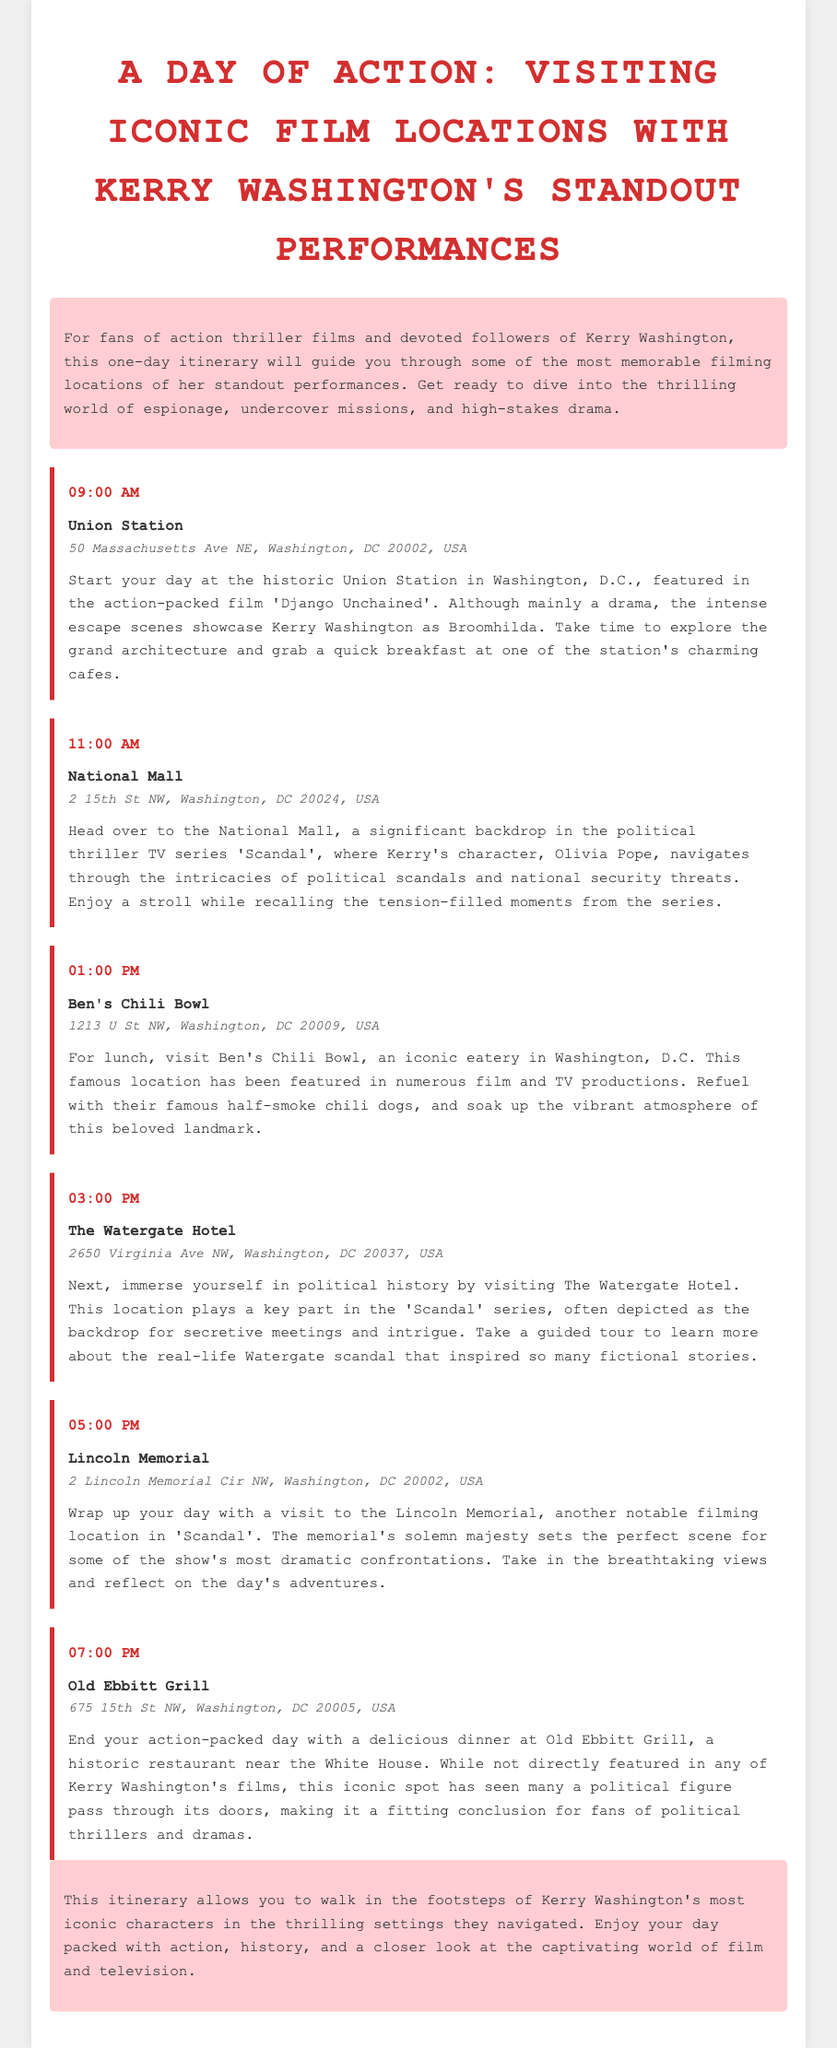what time does the day start? The itinerary starts at 09:00 AM, which is the time of the first event listed.
Answer: 09:00 AM where is the first location on the itinerary? The first location mentioned in the itinerary is Union Station.
Answer: Union Station what meal is planned at Ben's Chili Bowl? The document specifies that lunch is planned at Ben's Chili Bowl, where a meal consists of half-smoke chili dogs.
Answer: lunch which film features Union Station as a filming location? The itinerary indicates that Union Station is featured in 'Django Unchained'.
Answer: Django Unchained what significant political series is mentioned in relation to the National Mall? The National Mall is highlighted in connection with the political thriller TV series 'Scandal'.
Answer: Scandal how many events are scheduled for the day? By counting the events listed in the itinerary, there are a total of five events scheduled.
Answer: five what is the last location visited in the itinerary? The last location mentioned in the itinerary, before concluding the day, is the Old Ebbitt Grill.
Answer: Old Ebbitt Grill at what time does the day conclude? The final event in the itinerary takes place at 07:00 PM, marking the conclusion of the day.
Answer: 07:00 PM 